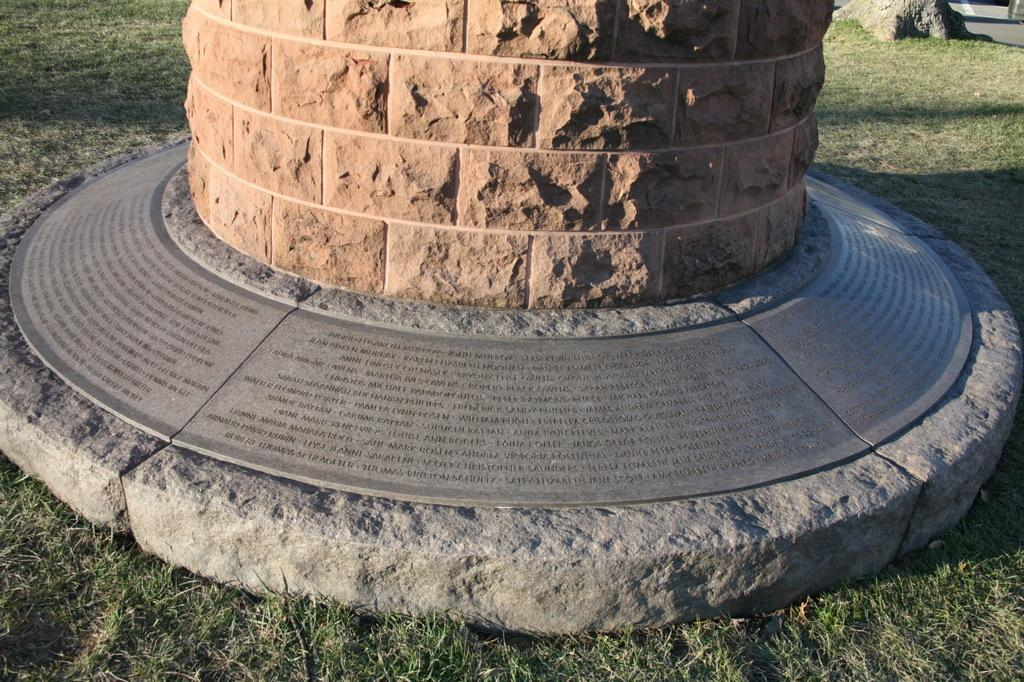What is written or depicted on the stone in the image? There are words carved on a stone in the image. What is the color and material of the pillar in the image? There is a brown color pillar in the image. What type of vegetation is present on the ground in the image? There is grass on the ground in the image. Can you tell me how the judge is reacting to the amusement park in the image? There is no judge or amusement park present in the image. The image features words carved on a stone, a brown color pillar, and grass on the ground. 